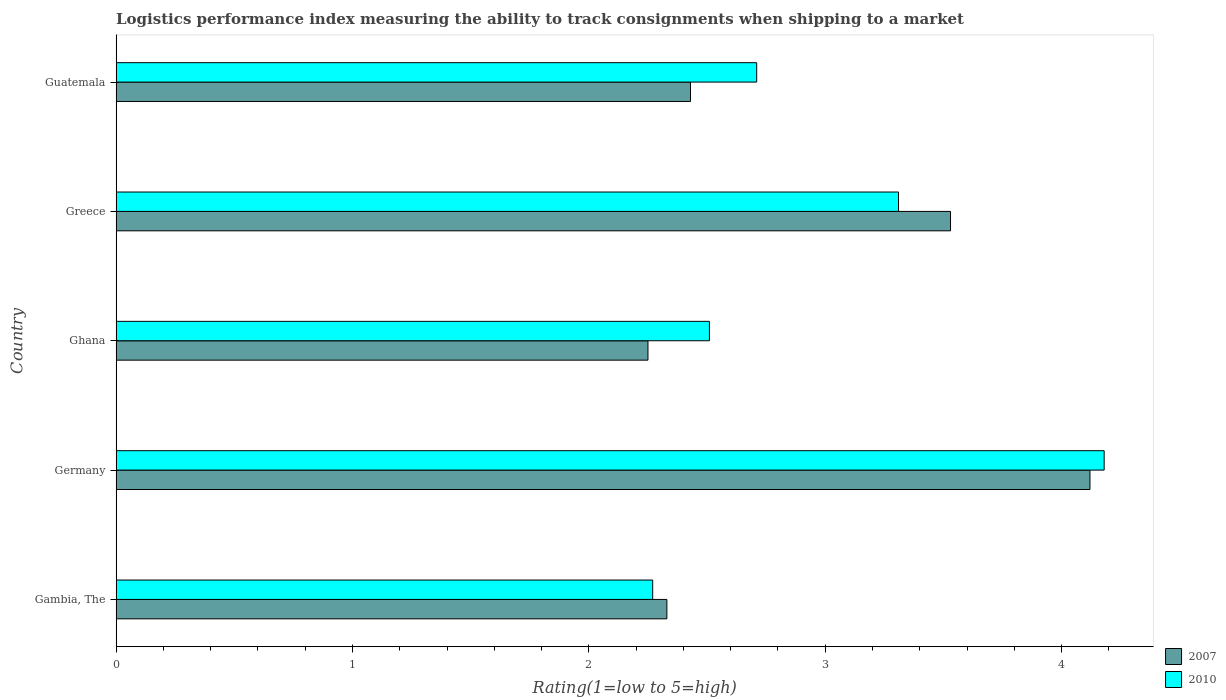How many different coloured bars are there?
Provide a short and direct response. 2. Are the number of bars on each tick of the Y-axis equal?
Keep it short and to the point. Yes. How many bars are there on the 1st tick from the top?
Make the answer very short. 2. How many bars are there on the 3rd tick from the bottom?
Offer a very short reply. 2. What is the label of the 4th group of bars from the top?
Offer a very short reply. Germany. What is the Logistic performance index in 2007 in Gambia, The?
Keep it short and to the point. 2.33. Across all countries, what is the maximum Logistic performance index in 2007?
Offer a terse response. 4.12. Across all countries, what is the minimum Logistic performance index in 2010?
Keep it short and to the point. 2.27. In which country was the Logistic performance index in 2010 maximum?
Offer a very short reply. Germany. In which country was the Logistic performance index in 2007 minimum?
Keep it short and to the point. Ghana. What is the total Logistic performance index in 2010 in the graph?
Give a very brief answer. 14.98. What is the difference between the Logistic performance index in 2007 in Gambia, The and that in Greece?
Provide a succinct answer. -1.2. What is the difference between the Logistic performance index in 2010 in Germany and the Logistic performance index in 2007 in Ghana?
Give a very brief answer. 1.93. What is the average Logistic performance index in 2007 per country?
Provide a short and direct response. 2.93. What is the difference between the Logistic performance index in 2007 and Logistic performance index in 2010 in Ghana?
Provide a short and direct response. -0.26. In how many countries, is the Logistic performance index in 2007 greater than 3.4 ?
Offer a very short reply. 2. What is the ratio of the Logistic performance index in 2010 in Gambia, The to that in Ghana?
Give a very brief answer. 0.9. Is the Logistic performance index in 2007 in Gambia, The less than that in Greece?
Offer a terse response. Yes. Is the difference between the Logistic performance index in 2007 in Gambia, The and Greece greater than the difference between the Logistic performance index in 2010 in Gambia, The and Greece?
Offer a very short reply. No. What is the difference between the highest and the second highest Logistic performance index in 2010?
Give a very brief answer. 0.87. What is the difference between the highest and the lowest Logistic performance index in 2007?
Provide a succinct answer. 1.87. Is the sum of the Logistic performance index in 2010 in Germany and Guatemala greater than the maximum Logistic performance index in 2007 across all countries?
Make the answer very short. Yes. What does the 1st bar from the top in Gambia, The represents?
Your answer should be compact. 2010. How many bars are there?
Your response must be concise. 10. What is the difference between two consecutive major ticks on the X-axis?
Your answer should be compact. 1. Are the values on the major ticks of X-axis written in scientific E-notation?
Your response must be concise. No. Does the graph contain grids?
Offer a very short reply. No. Where does the legend appear in the graph?
Your answer should be compact. Bottom right. How many legend labels are there?
Offer a terse response. 2. How are the legend labels stacked?
Provide a succinct answer. Vertical. What is the title of the graph?
Keep it short and to the point. Logistics performance index measuring the ability to track consignments when shipping to a market. What is the label or title of the X-axis?
Your answer should be very brief. Rating(1=low to 5=high). What is the Rating(1=low to 5=high) of 2007 in Gambia, The?
Make the answer very short. 2.33. What is the Rating(1=low to 5=high) in 2010 in Gambia, The?
Your answer should be very brief. 2.27. What is the Rating(1=low to 5=high) of 2007 in Germany?
Your answer should be compact. 4.12. What is the Rating(1=low to 5=high) in 2010 in Germany?
Offer a terse response. 4.18. What is the Rating(1=low to 5=high) of 2007 in Ghana?
Provide a short and direct response. 2.25. What is the Rating(1=low to 5=high) of 2010 in Ghana?
Provide a short and direct response. 2.51. What is the Rating(1=low to 5=high) in 2007 in Greece?
Keep it short and to the point. 3.53. What is the Rating(1=low to 5=high) in 2010 in Greece?
Provide a short and direct response. 3.31. What is the Rating(1=low to 5=high) of 2007 in Guatemala?
Make the answer very short. 2.43. What is the Rating(1=low to 5=high) of 2010 in Guatemala?
Give a very brief answer. 2.71. Across all countries, what is the maximum Rating(1=low to 5=high) of 2007?
Give a very brief answer. 4.12. Across all countries, what is the maximum Rating(1=low to 5=high) in 2010?
Keep it short and to the point. 4.18. Across all countries, what is the minimum Rating(1=low to 5=high) in 2007?
Ensure brevity in your answer.  2.25. Across all countries, what is the minimum Rating(1=low to 5=high) of 2010?
Offer a terse response. 2.27. What is the total Rating(1=low to 5=high) of 2007 in the graph?
Offer a very short reply. 14.66. What is the total Rating(1=low to 5=high) in 2010 in the graph?
Offer a very short reply. 14.98. What is the difference between the Rating(1=low to 5=high) of 2007 in Gambia, The and that in Germany?
Your answer should be compact. -1.79. What is the difference between the Rating(1=low to 5=high) of 2010 in Gambia, The and that in Germany?
Ensure brevity in your answer.  -1.91. What is the difference between the Rating(1=low to 5=high) in 2010 in Gambia, The and that in Ghana?
Make the answer very short. -0.24. What is the difference between the Rating(1=low to 5=high) in 2007 in Gambia, The and that in Greece?
Your answer should be very brief. -1.2. What is the difference between the Rating(1=low to 5=high) of 2010 in Gambia, The and that in Greece?
Keep it short and to the point. -1.04. What is the difference between the Rating(1=low to 5=high) of 2010 in Gambia, The and that in Guatemala?
Make the answer very short. -0.44. What is the difference between the Rating(1=low to 5=high) in 2007 in Germany and that in Ghana?
Provide a succinct answer. 1.87. What is the difference between the Rating(1=low to 5=high) of 2010 in Germany and that in Ghana?
Provide a succinct answer. 1.67. What is the difference between the Rating(1=low to 5=high) in 2007 in Germany and that in Greece?
Keep it short and to the point. 0.59. What is the difference between the Rating(1=low to 5=high) of 2010 in Germany and that in Greece?
Provide a short and direct response. 0.87. What is the difference between the Rating(1=low to 5=high) in 2007 in Germany and that in Guatemala?
Your response must be concise. 1.69. What is the difference between the Rating(1=low to 5=high) in 2010 in Germany and that in Guatemala?
Offer a terse response. 1.47. What is the difference between the Rating(1=low to 5=high) in 2007 in Ghana and that in Greece?
Offer a terse response. -1.28. What is the difference between the Rating(1=low to 5=high) of 2010 in Ghana and that in Greece?
Your answer should be very brief. -0.8. What is the difference between the Rating(1=low to 5=high) of 2007 in Ghana and that in Guatemala?
Your answer should be very brief. -0.18. What is the difference between the Rating(1=low to 5=high) of 2010 in Ghana and that in Guatemala?
Provide a short and direct response. -0.2. What is the difference between the Rating(1=low to 5=high) of 2007 in Gambia, The and the Rating(1=low to 5=high) of 2010 in Germany?
Provide a succinct answer. -1.85. What is the difference between the Rating(1=low to 5=high) of 2007 in Gambia, The and the Rating(1=low to 5=high) of 2010 in Ghana?
Give a very brief answer. -0.18. What is the difference between the Rating(1=low to 5=high) in 2007 in Gambia, The and the Rating(1=low to 5=high) in 2010 in Greece?
Your response must be concise. -0.98. What is the difference between the Rating(1=low to 5=high) of 2007 in Gambia, The and the Rating(1=low to 5=high) of 2010 in Guatemala?
Ensure brevity in your answer.  -0.38. What is the difference between the Rating(1=low to 5=high) in 2007 in Germany and the Rating(1=low to 5=high) in 2010 in Ghana?
Ensure brevity in your answer.  1.61. What is the difference between the Rating(1=low to 5=high) of 2007 in Germany and the Rating(1=low to 5=high) of 2010 in Greece?
Your answer should be compact. 0.81. What is the difference between the Rating(1=low to 5=high) in 2007 in Germany and the Rating(1=low to 5=high) in 2010 in Guatemala?
Offer a very short reply. 1.41. What is the difference between the Rating(1=low to 5=high) of 2007 in Ghana and the Rating(1=low to 5=high) of 2010 in Greece?
Your answer should be compact. -1.06. What is the difference between the Rating(1=low to 5=high) of 2007 in Ghana and the Rating(1=low to 5=high) of 2010 in Guatemala?
Provide a short and direct response. -0.46. What is the difference between the Rating(1=low to 5=high) in 2007 in Greece and the Rating(1=low to 5=high) in 2010 in Guatemala?
Offer a terse response. 0.82. What is the average Rating(1=low to 5=high) in 2007 per country?
Give a very brief answer. 2.93. What is the average Rating(1=low to 5=high) of 2010 per country?
Offer a very short reply. 3. What is the difference between the Rating(1=low to 5=high) in 2007 and Rating(1=low to 5=high) in 2010 in Germany?
Give a very brief answer. -0.06. What is the difference between the Rating(1=low to 5=high) in 2007 and Rating(1=low to 5=high) in 2010 in Ghana?
Provide a succinct answer. -0.26. What is the difference between the Rating(1=low to 5=high) of 2007 and Rating(1=low to 5=high) of 2010 in Greece?
Keep it short and to the point. 0.22. What is the difference between the Rating(1=low to 5=high) in 2007 and Rating(1=low to 5=high) in 2010 in Guatemala?
Offer a very short reply. -0.28. What is the ratio of the Rating(1=low to 5=high) in 2007 in Gambia, The to that in Germany?
Give a very brief answer. 0.57. What is the ratio of the Rating(1=low to 5=high) of 2010 in Gambia, The to that in Germany?
Give a very brief answer. 0.54. What is the ratio of the Rating(1=low to 5=high) in 2007 in Gambia, The to that in Ghana?
Offer a terse response. 1.04. What is the ratio of the Rating(1=low to 5=high) of 2010 in Gambia, The to that in Ghana?
Your response must be concise. 0.9. What is the ratio of the Rating(1=low to 5=high) in 2007 in Gambia, The to that in Greece?
Your response must be concise. 0.66. What is the ratio of the Rating(1=low to 5=high) of 2010 in Gambia, The to that in Greece?
Your answer should be very brief. 0.69. What is the ratio of the Rating(1=low to 5=high) in 2007 in Gambia, The to that in Guatemala?
Provide a succinct answer. 0.96. What is the ratio of the Rating(1=low to 5=high) in 2010 in Gambia, The to that in Guatemala?
Provide a short and direct response. 0.84. What is the ratio of the Rating(1=low to 5=high) in 2007 in Germany to that in Ghana?
Ensure brevity in your answer.  1.83. What is the ratio of the Rating(1=low to 5=high) in 2010 in Germany to that in Ghana?
Your answer should be very brief. 1.67. What is the ratio of the Rating(1=low to 5=high) of 2007 in Germany to that in Greece?
Offer a very short reply. 1.17. What is the ratio of the Rating(1=low to 5=high) of 2010 in Germany to that in Greece?
Provide a short and direct response. 1.26. What is the ratio of the Rating(1=low to 5=high) in 2007 in Germany to that in Guatemala?
Offer a very short reply. 1.7. What is the ratio of the Rating(1=low to 5=high) in 2010 in Germany to that in Guatemala?
Provide a succinct answer. 1.54. What is the ratio of the Rating(1=low to 5=high) in 2007 in Ghana to that in Greece?
Your answer should be very brief. 0.64. What is the ratio of the Rating(1=low to 5=high) in 2010 in Ghana to that in Greece?
Keep it short and to the point. 0.76. What is the ratio of the Rating(1=low to 5=high) in 2007 in Ghana to that in Guatemala?
Your answer should be compact. 0.93. What is the ratio of the Rating(1=low to 5=high) of 2010 in Ghana to that in Guatemala?
Your answer should be compact. 0.93. What is the ratio of the Rating(1=low to 5=high) of 2007 in Greece to that in Guatemala?
Ensure brevity in your answer.  1.45. What is the ratio of the Rating(1=low to 5=high) of 2010 in Greece to that in Guatemala?
Your answer should be compact. 1.22. What is the difference between the highest and the second highest Rating(1=low to 5=high) in 2007?
Give a very brief answer. 0.59. What is the difference between the highest and the second highest Rating(1=low to 5=high) in 2010?
Offer a terse response. 0.87. What is the difference between the highest and the lowest Rating(1=low to 5=high) in 2007?
Provide a short and direct response. 1.87. What is the difference between the highest and the lowest Rating(1=low to 5=high) of 2010?
Keep it short and to the point. 1.91. 